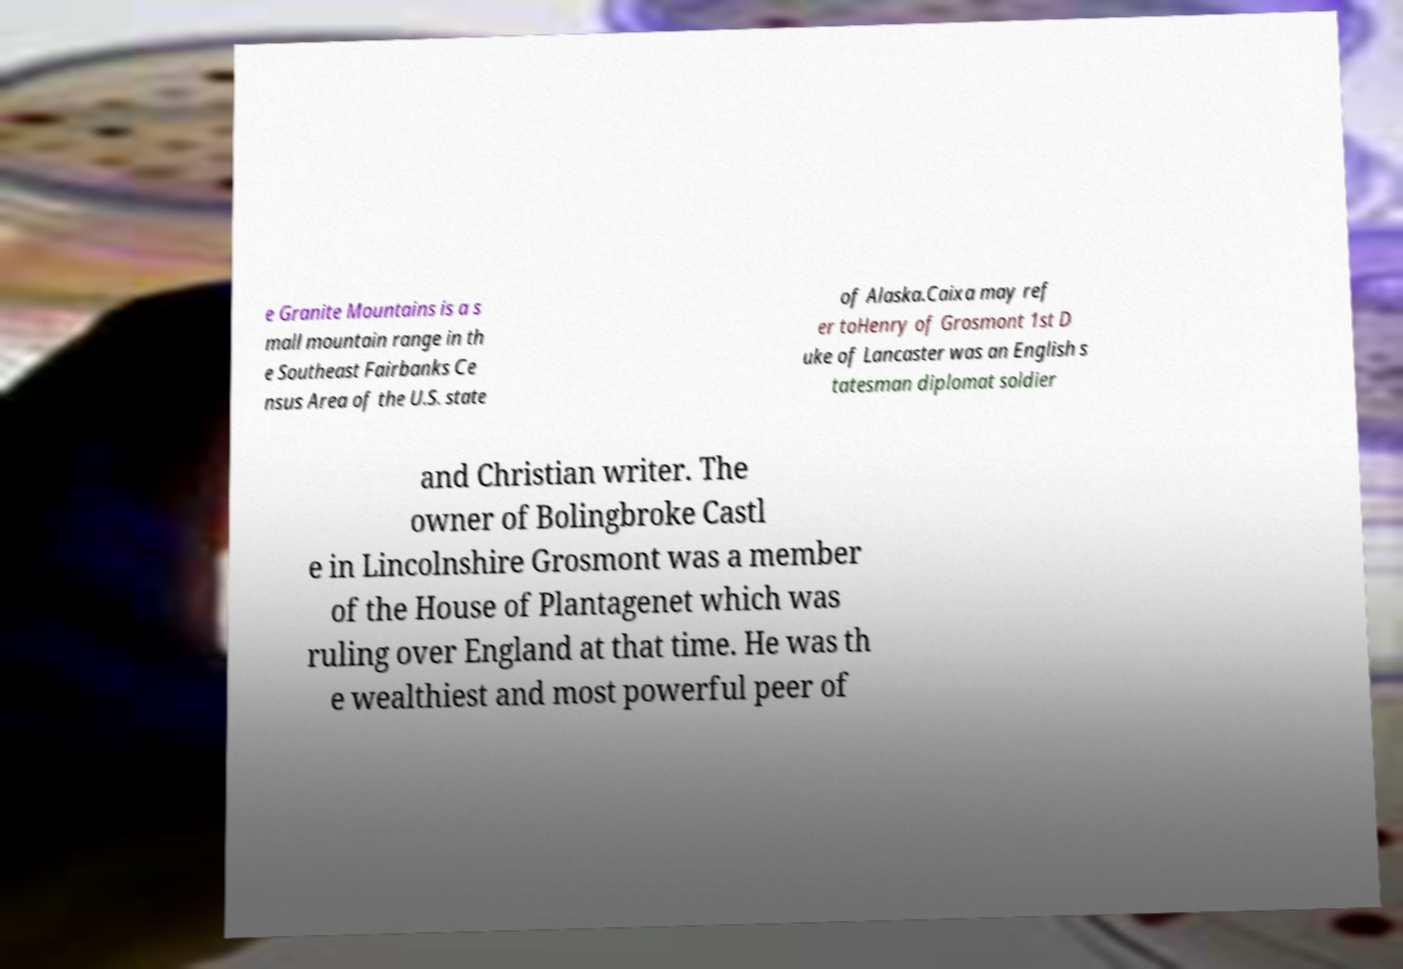There's text embedded in this image that I need extracted. Can you transcribe it verbatim? e Granite Mountains is a s mall mountain range in th e Southeast Fairbanks Ce nsus Area of the U.S. state of Alaska.Caixa may ref er toHenry of Grosmont 1st D uke of Lancaster was an English s tatesman diplomat soldier and Christian writer. The owner of Bolingbroke Castl e in Lincolnshire Grosmont was a member of the House of Plantagenet which was ruling over England at that time. He was th e wealthiest and most powerful peer of 